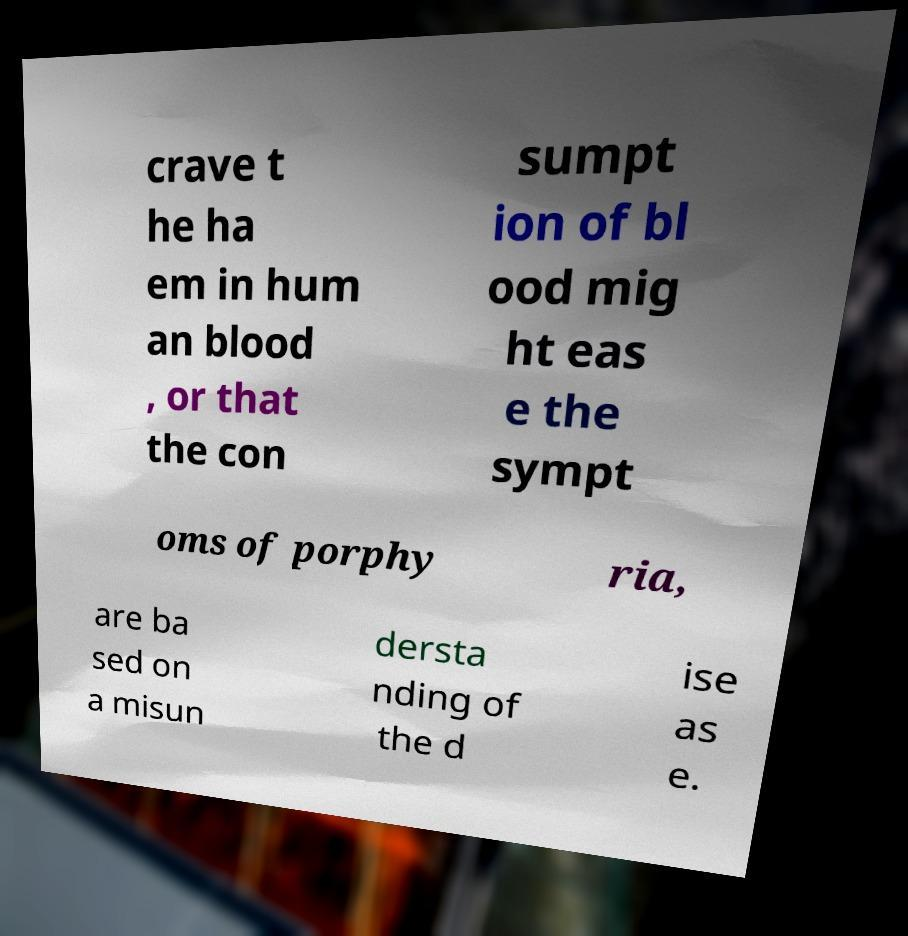There's text embedded in this image that I need extracted. Can you transcribe it verbatim? crave t he ha em in hum an blood , or that the con sumpt ion of bl ood mig ht eas e the sympt oms of porphy ria, are ba sed on a misun dersta nding of the d ise as e. 